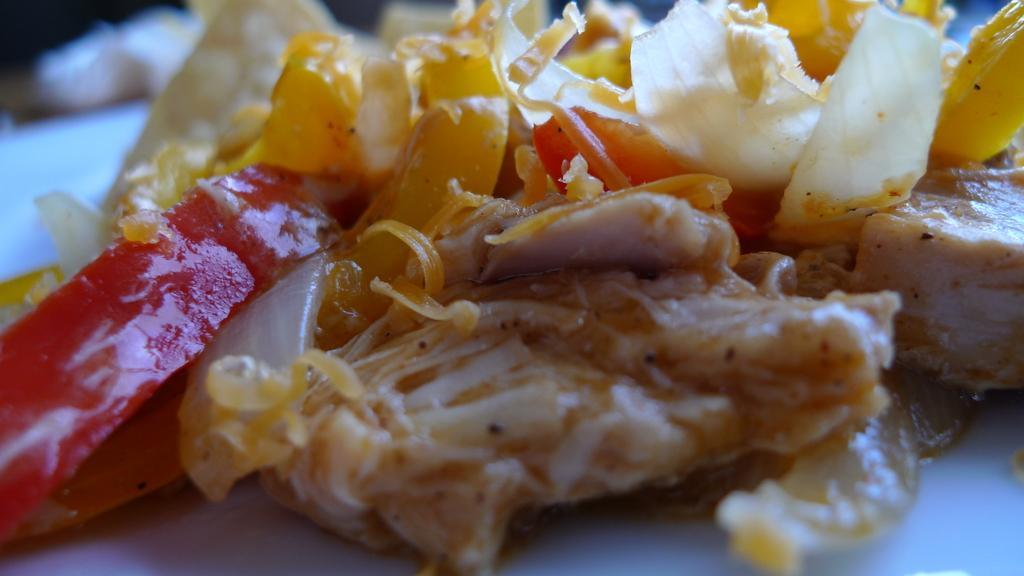Could you give a brief overview of what you see in this image? In this image I can see the food which is in red, yellow and cream color. It is on the white color surface. And there is a blurred background. 